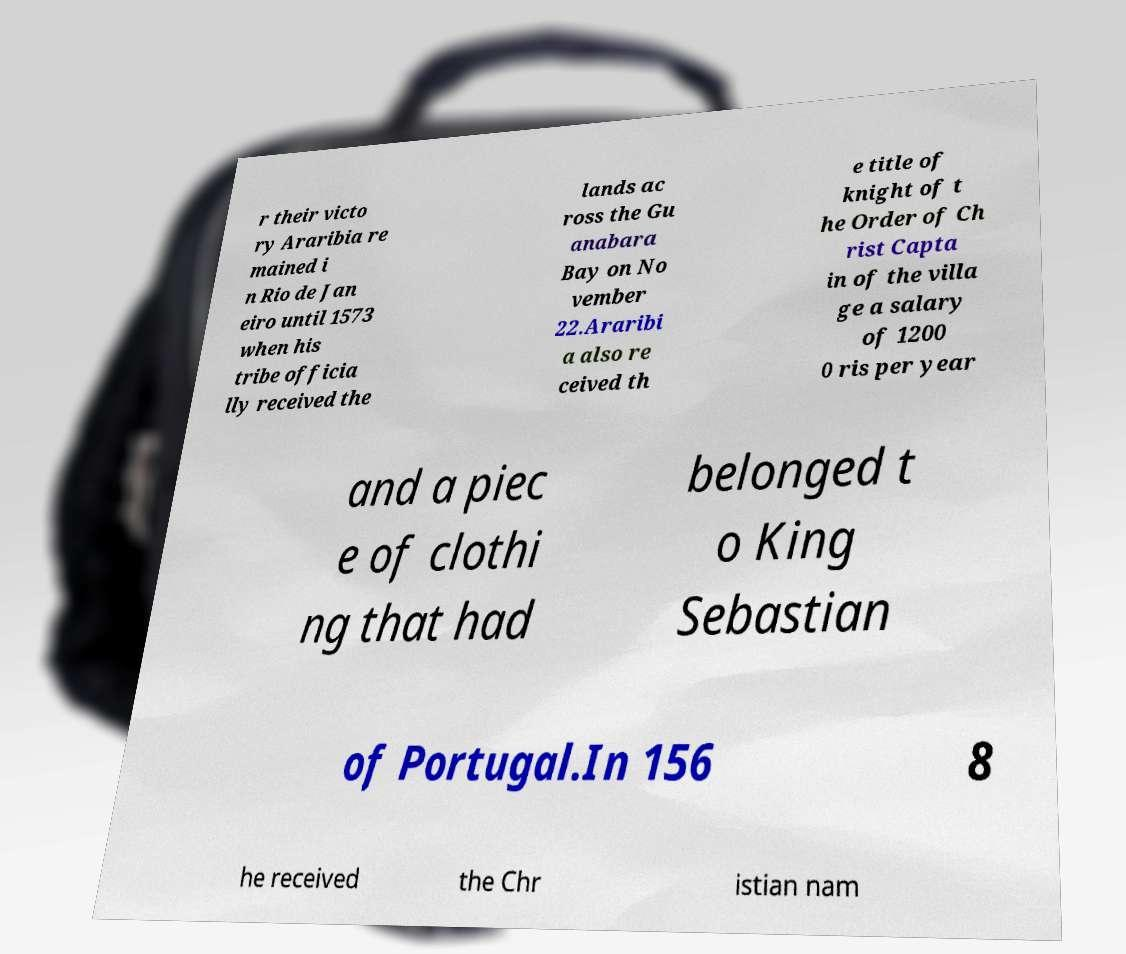Can you read and provide the text displayed in the image?This photo seems to have some interesting text. Can you extract and type it out for me? r their victo ry Araribia re mained i n Rio de Jan eiro until 1573 when his tribe officia lly received the lands ac ross the Gu anabara Bay on No vember 22.Araribi a also re ceived th e title of knight of t he Order of Ch rist Capta in of the villa ge a salary of 1200 0 ris per year and a piec e of clothi ng that had belonged t o King Sebastian of Portugal.In 156 8 he received the Chr istian nam 